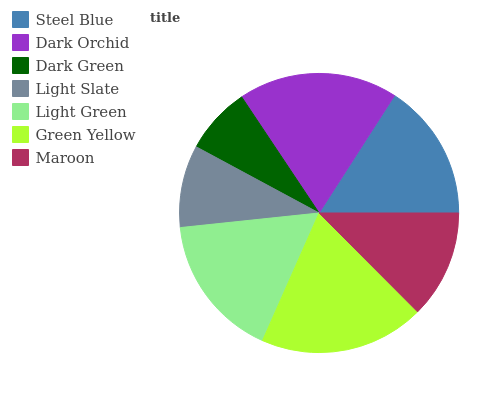Is Dark Green the minimum?
Answer yes or no. Yes. Is Green Yellow the maximum?
Answer yes or no. Yes. Is Dark Orchid the minimum?
Answer yes or no. No. Is Dark Orchid the maximum?
Answer yes or no. No. Is Dark Orchid greater than Steel Blue?
Answer yes or no. Yes. Is Steel Blue less than Dark Orchid?
Answer yes or no. Yes. Is Steel Blue greater than Dark Orchid?
Answer yes or no. No. Is Dark Orchid less than Steel Blue?
Answer yes or no. No. Is Steel Blue the high median?
Answer yes or no. Yes. Is Steel Blue the low median?
Answer yes or no. Yes. Is Light Slate the high median?
Answer yes or no. No. Is Light Slate the low median?
Answer yes or no. No. 